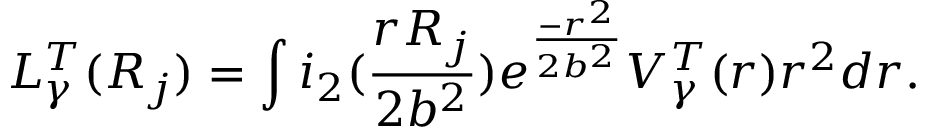Convert formula to latex. <formula><loc_0><loc_0><loc_500><loc_500>L _ { \gamma } ^ { T } ( R _ { j } ) = \int i _ { 2 } ( \frac { r R _ { j } } { 2 b ^ { 2 } } ) e ^ { \frac { - r ^ { 2 } } { 2 b ^ { 2 } } } V _ { \gamma } ^ { T } ( r ) r ^ { 2 } d r .</formula> 